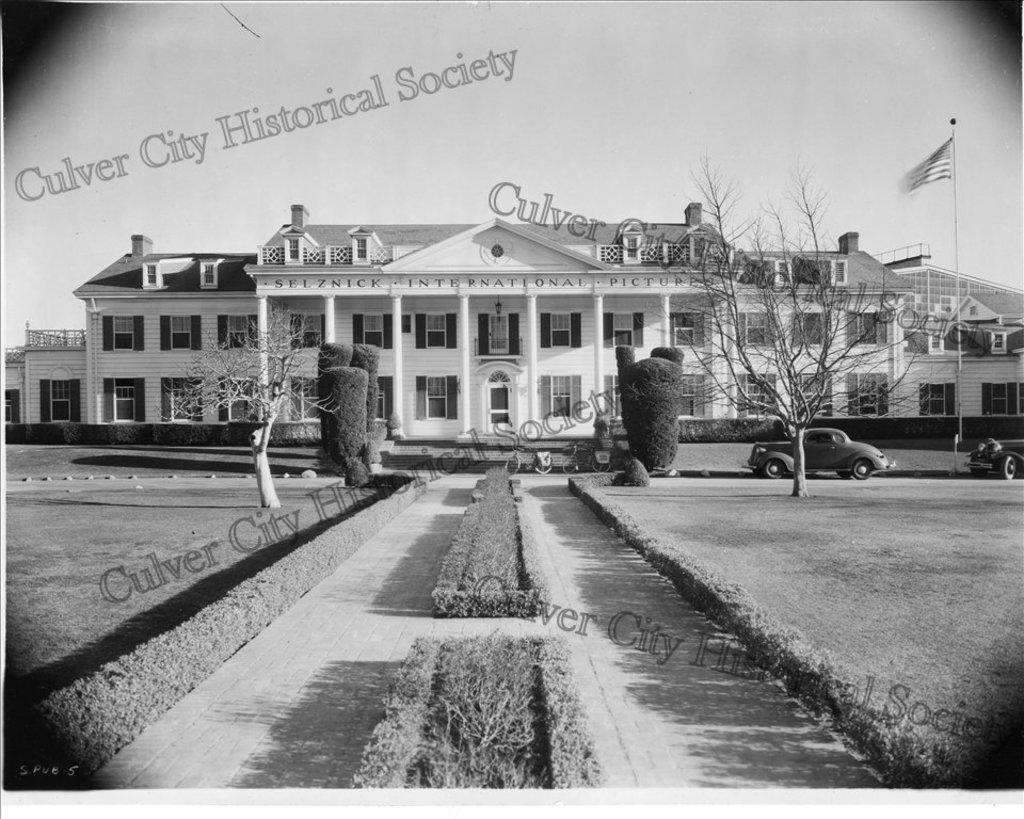What types of objects are present in the image? There are vehicles, trees, a flag, and a building with windows in the image. Can you describe the building in the image? The building has windows and is located in the image. What is visible in the background of the image? The sky is visible in the background of the image. What is the color scheme of the image? The image is in black and white. What type of animal can be seen twisting in the image? There are no animals present in the image, and no twisting is depicted. Can you describe the ray of light in the image? There is no ray of light present in the image; it is in black and white. 